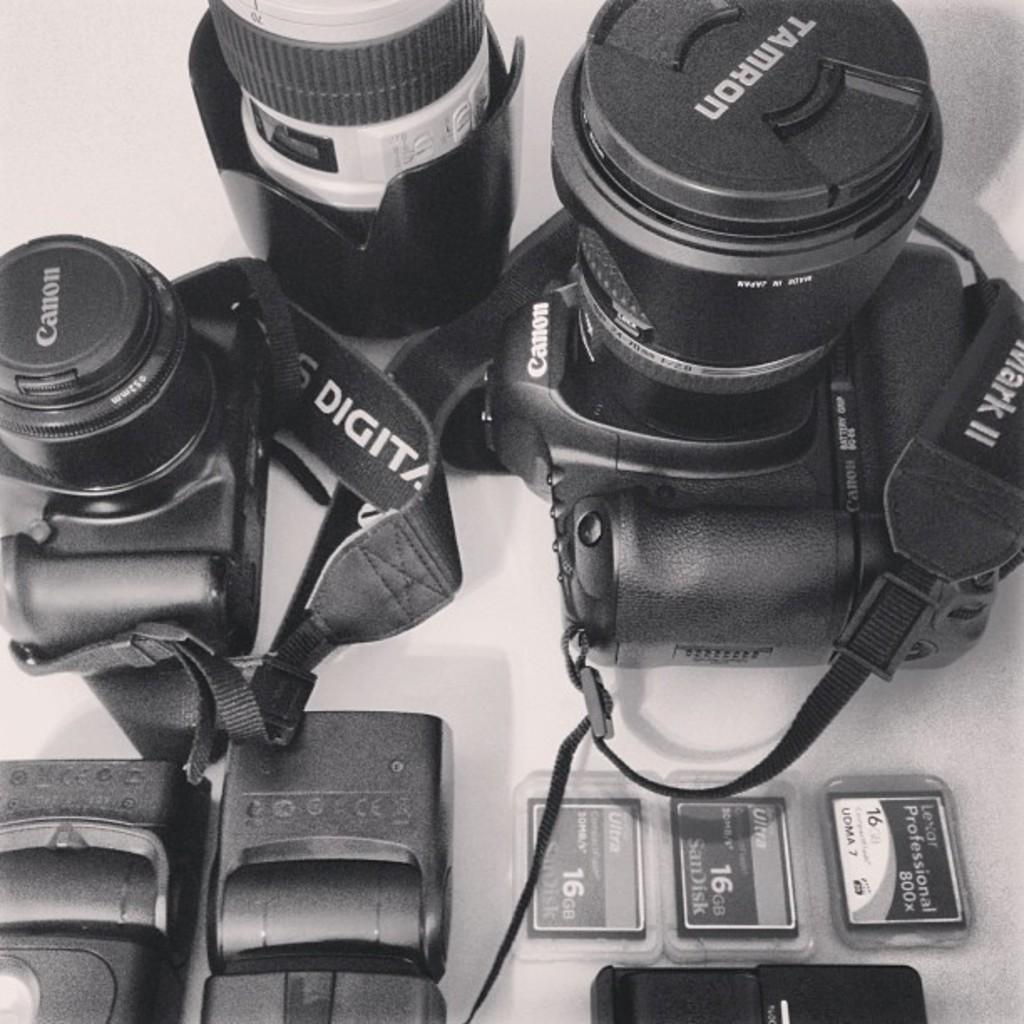Could you give a brief overview of what you see in this image? In this image I can see the cameras, cards and few more objects on the white color surface. 